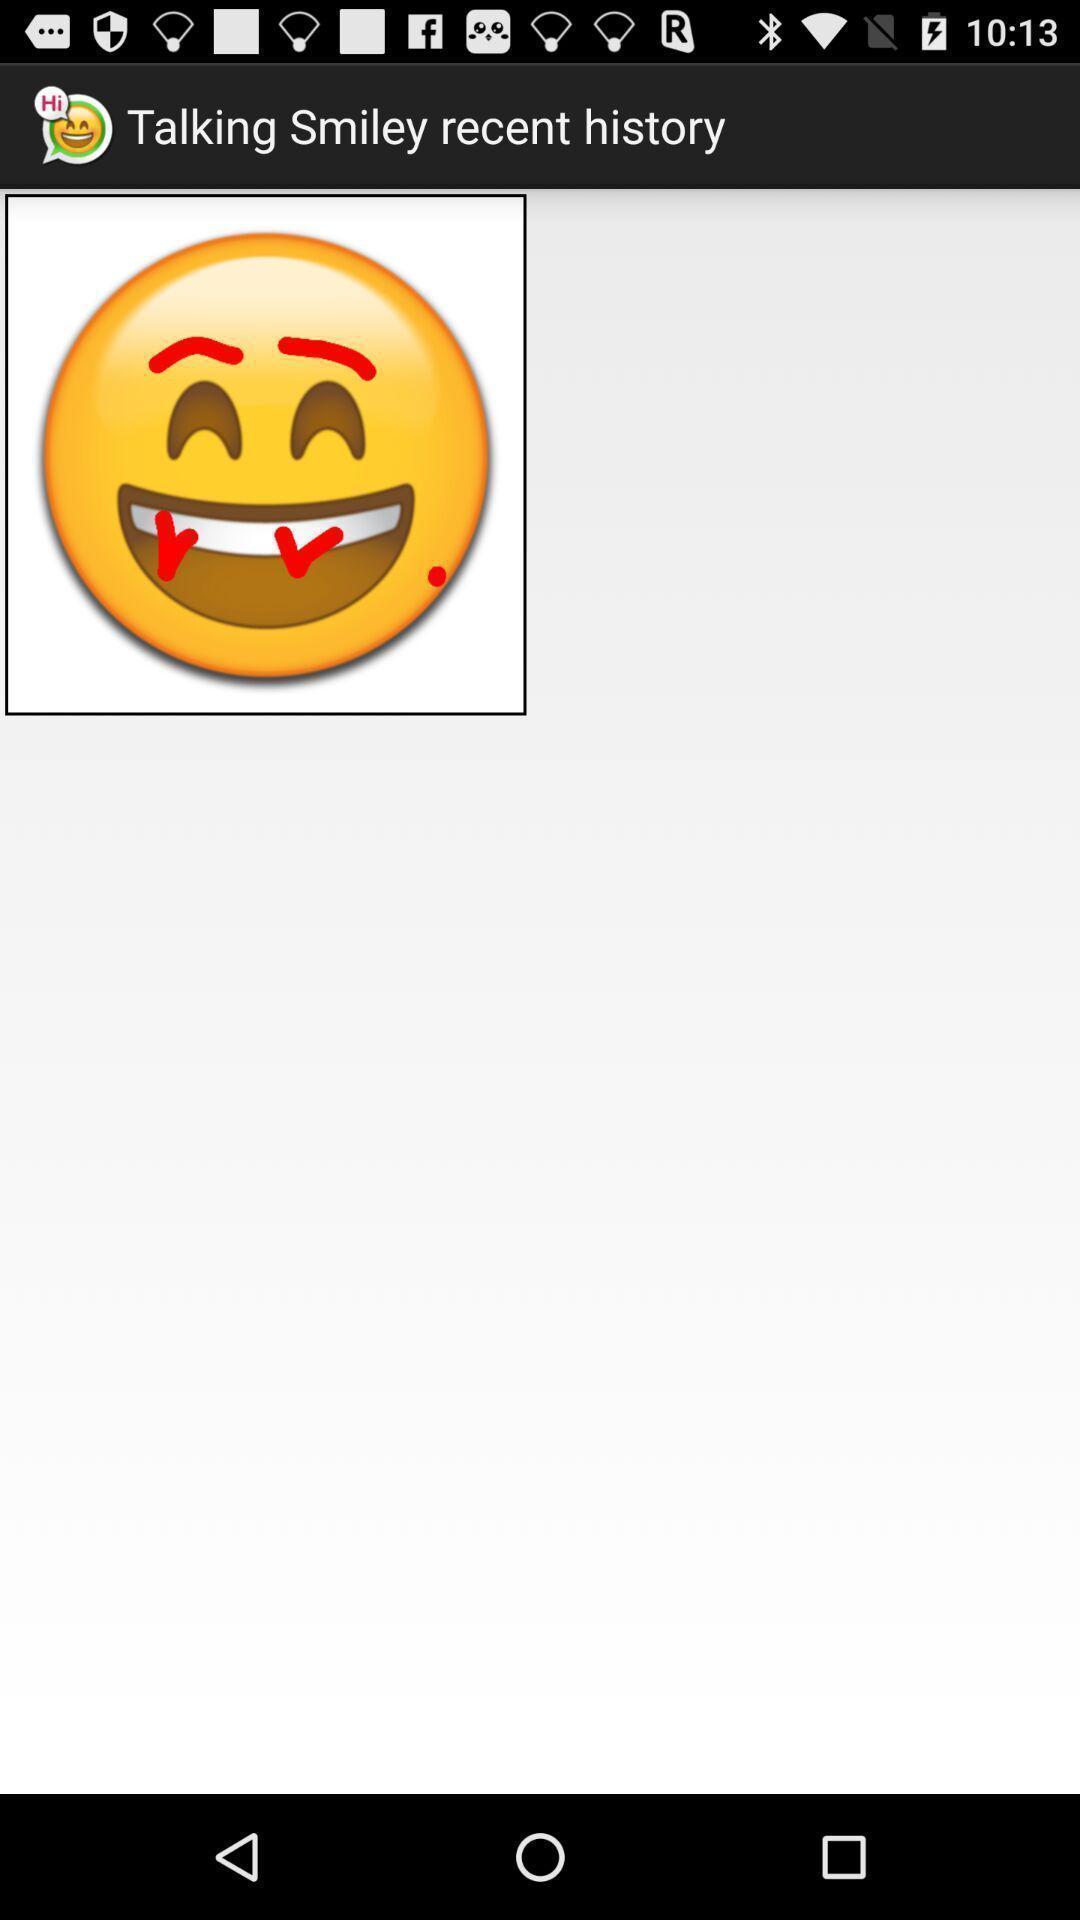Provide a textual representation of this image. Smiley emoji showing in this page. 